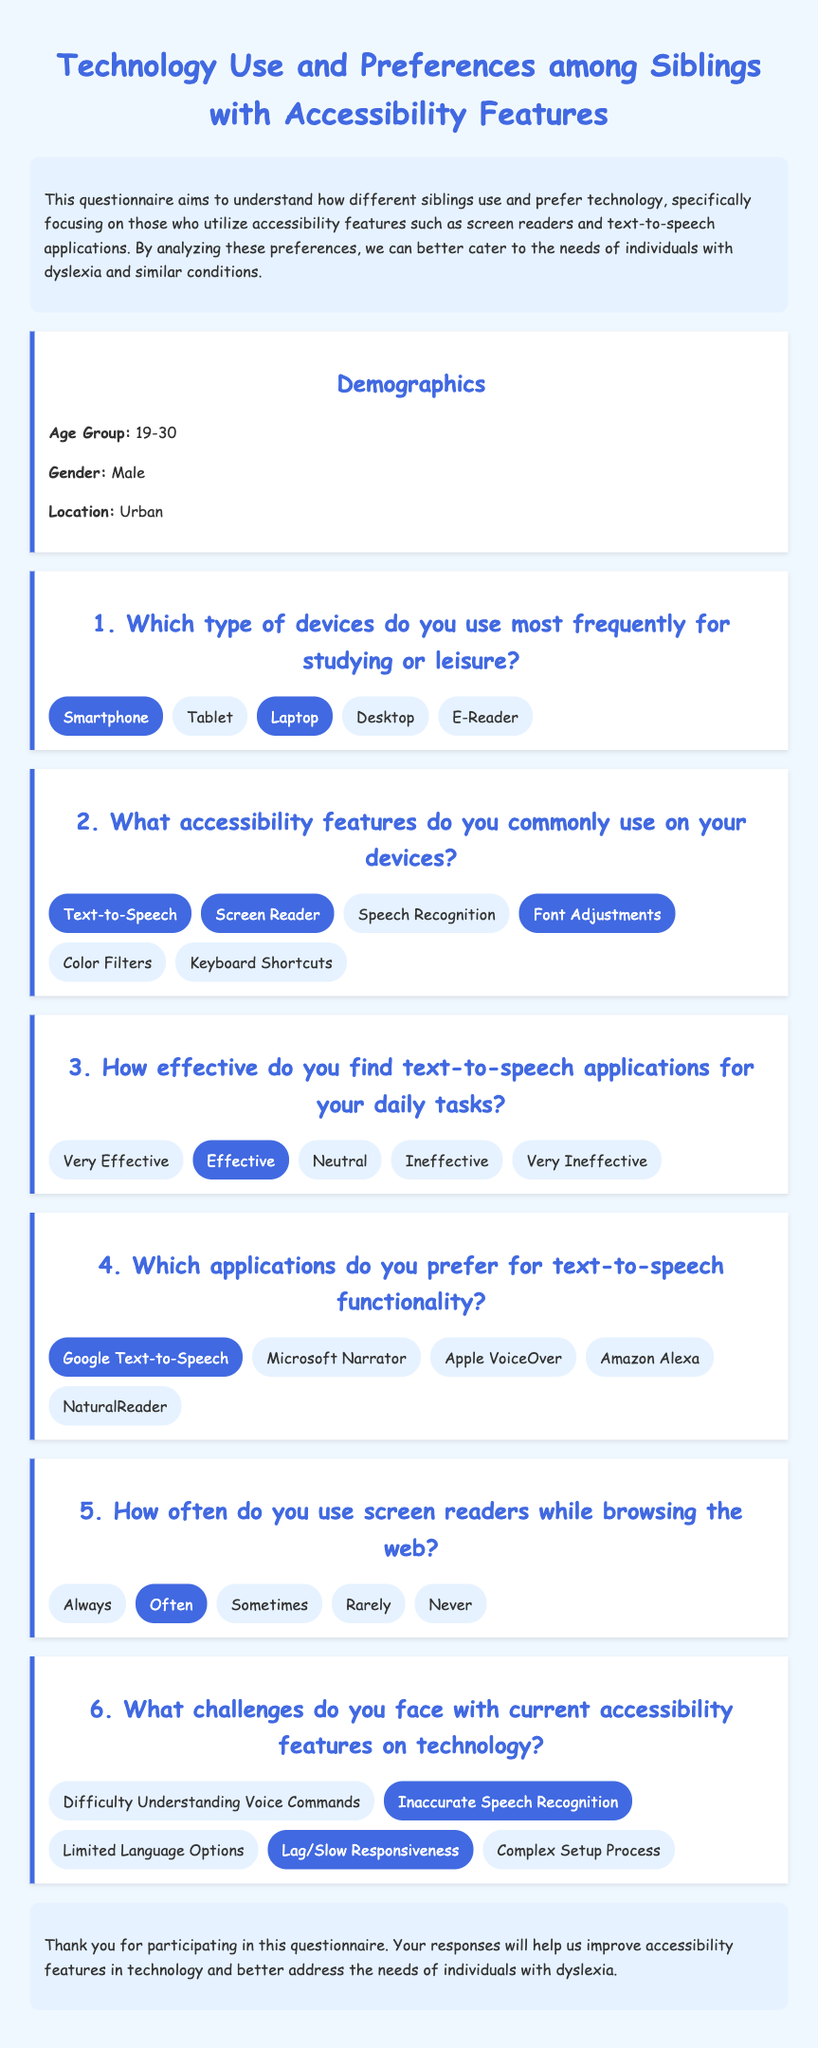What is the age group of the respondent? The age group is listed in the demographics section of the document as 19-30.
Answer: 19-30 Which devices are mentioned as used frequently for studying or leisure? The options listed for devices used frequently include smartphone, tablet, laptop, desktop, and e-reader.
Answer: Smartphone, Laptop What accessibility features does the respondent use? The accessibility features mentioned include text-to-speech, screen reader, font adjustments, and others.
Answer: Text-to-Speech, Screen Reader, Font Adjustments How effective does the respondent find text-to-speech applications? The effectiveness scale includes ranges from very effective to very ineffective; the selected option is effective.
Answer: Effective Which text-to-speech application does the respondent prefer? The respondent indicated a preference for Google Text-to-Speech among the listed applications.
Answer: Google Text-to-Speech How often does the respondent use screen readers while browsing? The frequency options include always, often, sometimes, rarely, and never; the selected option is often.
Answer: Often What is a reported challenge with accessibility features? The challenges involve issues like inaccurate speech recognition and lag/slow responsiveness; both are selected.
Answer: Inaccurate Speech Recognition, Lag/Slow Responsiveness What is the document's main aim? The introduction states that the aim is to understand how siblings use and prefer technology with accessibility features.
Answer: Understand technology use and preferences What is the tone of the document's design? The overall design reflects a friendly and easy-to-read tone with its chosen font and colors.
Answer: Friendly and easy-to-read 